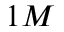Convert formula to latex. <formula><loc_0><loc_0><loc_500><loc_500>1 M</formula> 